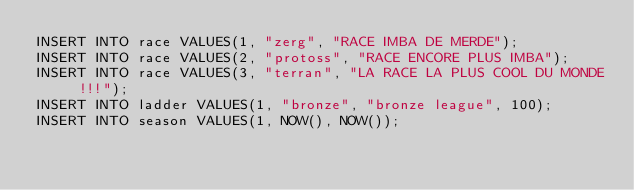Convert code to text. <code><loc_0><loc_0><loc_500><loc_500><_SQL_>INSERT INTO race VALUES(1, "zerg", "RACE IMBA DE MERDE");
INSERT INTO race VALUES(2, "protoss", "RACE ENCORE PLUS IMBA");
INSERT INTO race VALUES(3, "terran", "LA RACE LA PLUS COOL DU MONDE !!!");
INSERT INTO ladder VALUES(1, "bronze", "bronze league", 100);
INSERT INTO season VALUES(1, NOW(), NOW());
</code> 